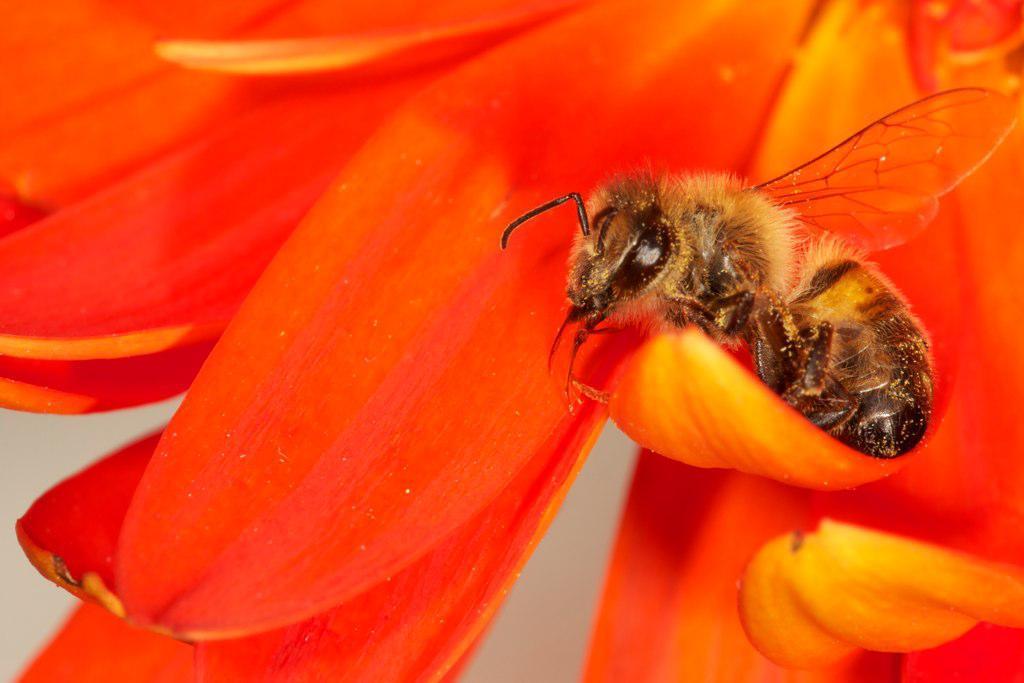In one or two sentences, can you explain what this image depicts? In this image I can see a bee on a flower. This image is taken, may be in a garden. 